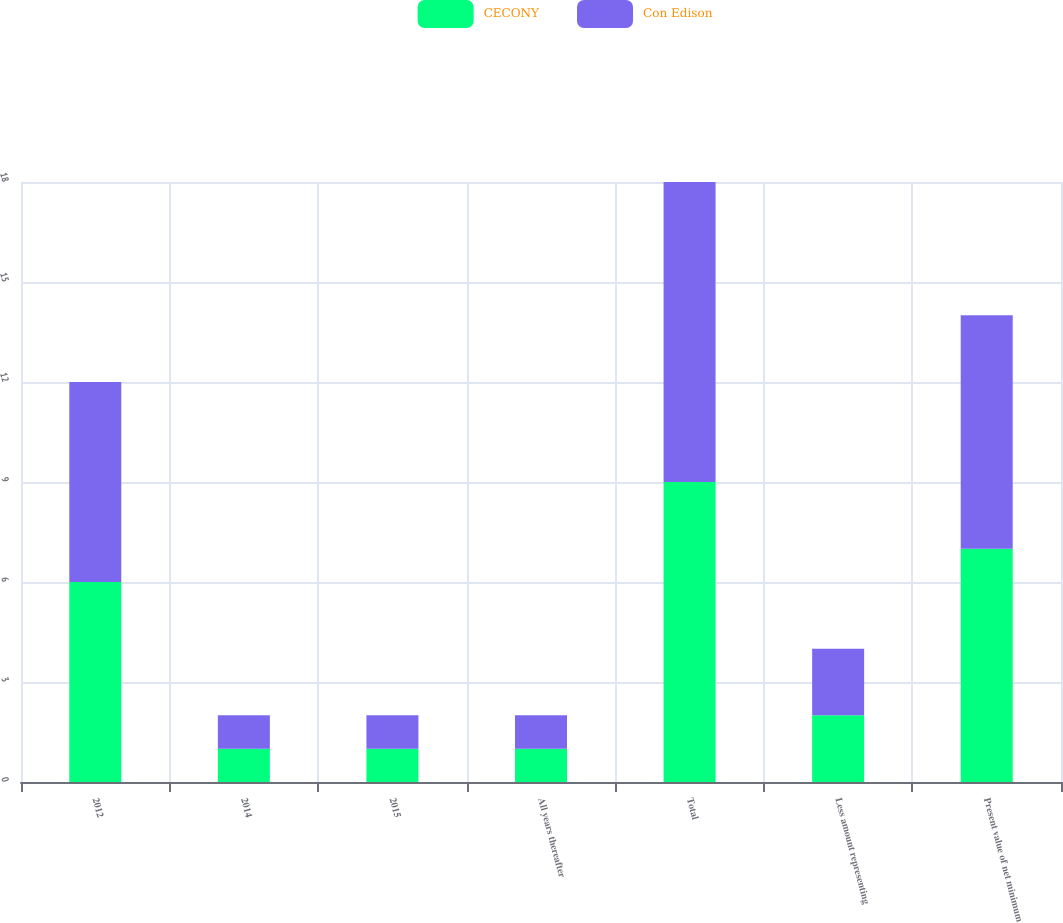Convert chart to OTSL. <chart><loc_0><loc_0><loc_500><loc_500><stacked_bar_chart><ecel><fcel>2012<fcel>2014<fcel>2015<fcel>All years thereafter<fcel>Total<fcel>Less amount representing<fcel>Present value of net minimum<nl><fcel>CECONY<fcel>6<fcel>1<fcel>1<fcel>1<fcel>9<fcel>2<fcel>7<nl><fcel>Con Edison<fcel>6<fcel>1<fcel>1<fcel>1<fcel>9<fcel>2<fcel>7<nl></chart> 